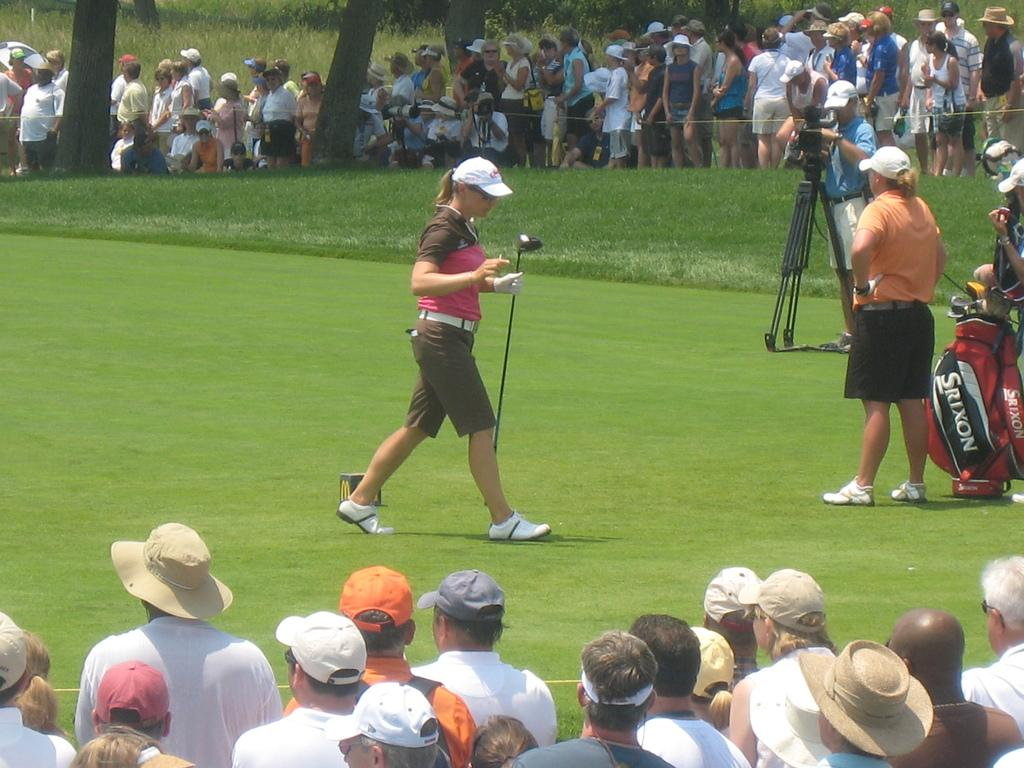<image>
Give a short and clear explanation of the subsequent image. A golf player is walking around and nearby is a golf bag with the word, Srixon, on it. 